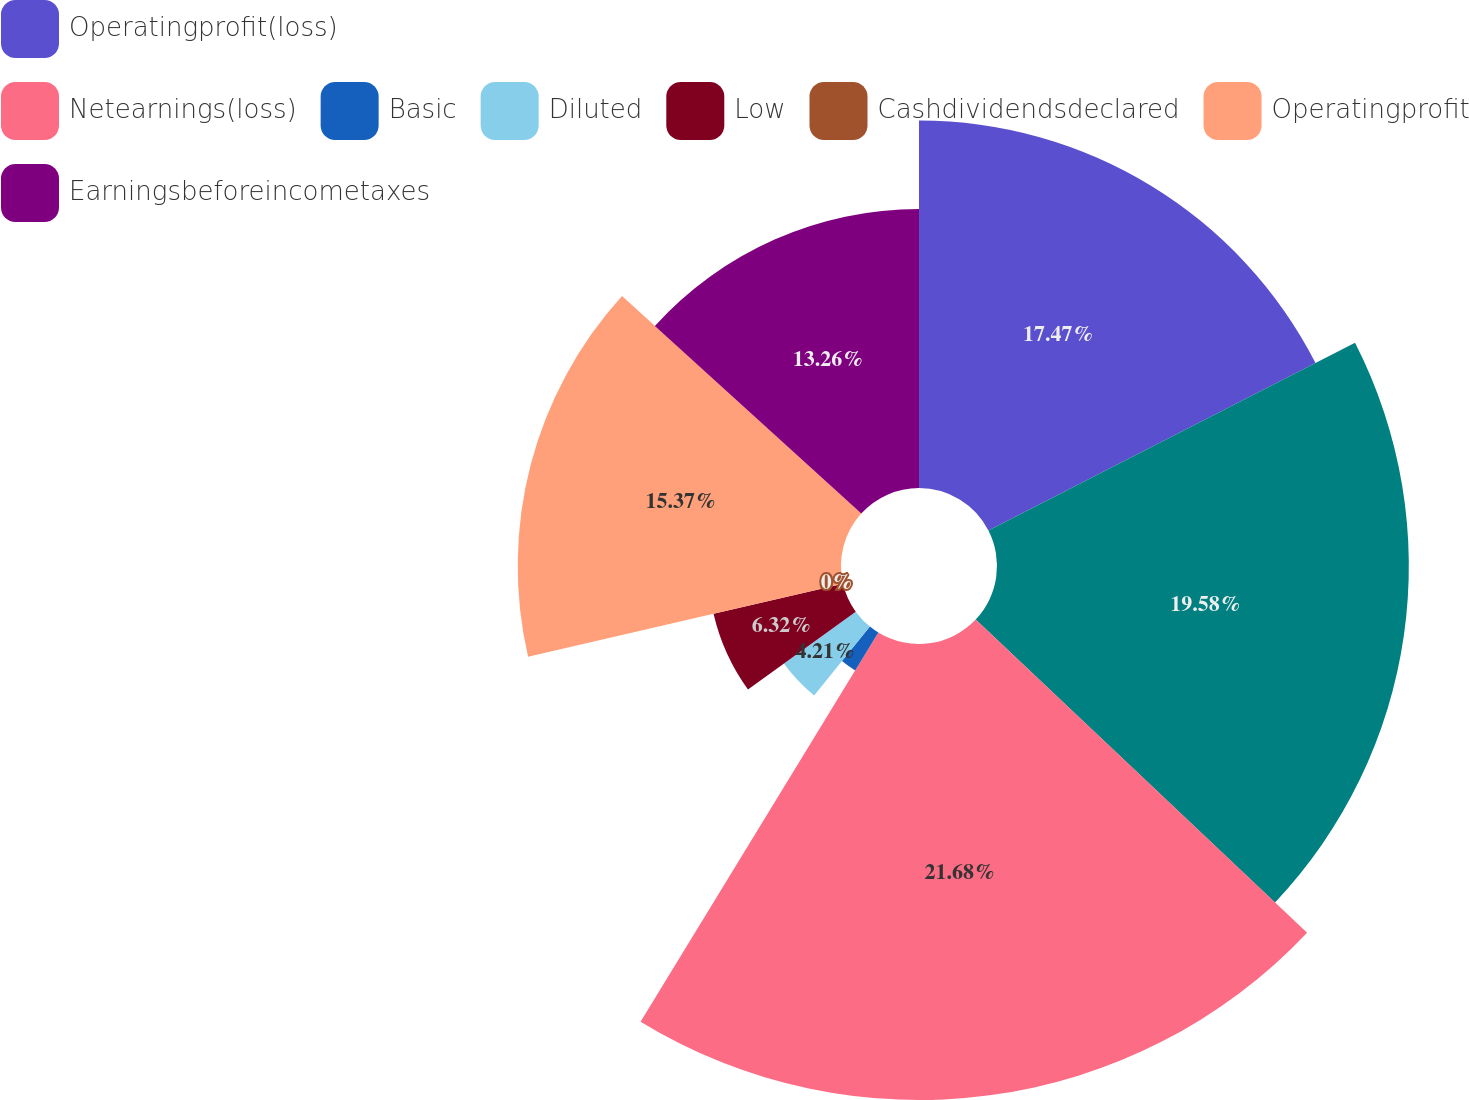Convert chart. <chart><loc_0><loc_0><loc_500><loc_500><pie_chart><fcel>Operatingprofit(loss)<fcel>Unnamed: 1<fcel>Netearnings(loss)<fcel>Basic<fcel>Diluted<fcel>Low<fcel>Cashdividendsdeclared<fcel>Operatingprofit<fcel>Earningsbeforeincometaxes<nl><fcel>17.47%<fcel>19.58%<fcel>21.68%<fcel>2.11%<fcel>4.21%<fcel>6.32%<fcel>0.0%<fcel>15.37%<fcel>13.26%<nl></chart> 